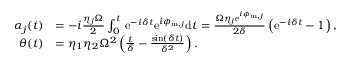<formula> <loc_0><loc_0><loc_500><loc_500>\begin{array} { r l } { \alpha _ { j } ( t ) } & { = - i \frac { \eta _ { j } \Omega } { 2 } \int _ { 0 } ^ { t } \, e ^ { - i \delta t } e ^ { i \phi _ { m , j } } d t = \frac { \Omega \eta _ { j } e ^ { i \phi _ { m , j } } } { 2 \delta } \left ( e ^ { - i \delta t } - 1 \right ) , } \\ { \theta ( t ) } & { = \eta _ { 1 } \eta _ { 2 } \Omega ^ { 2 } \left ( \frac { t } { \delta } - \frac { \sin ( \delta t ) } { \delta ^ { 2 } } \right ) . } \end{array}</formula> 